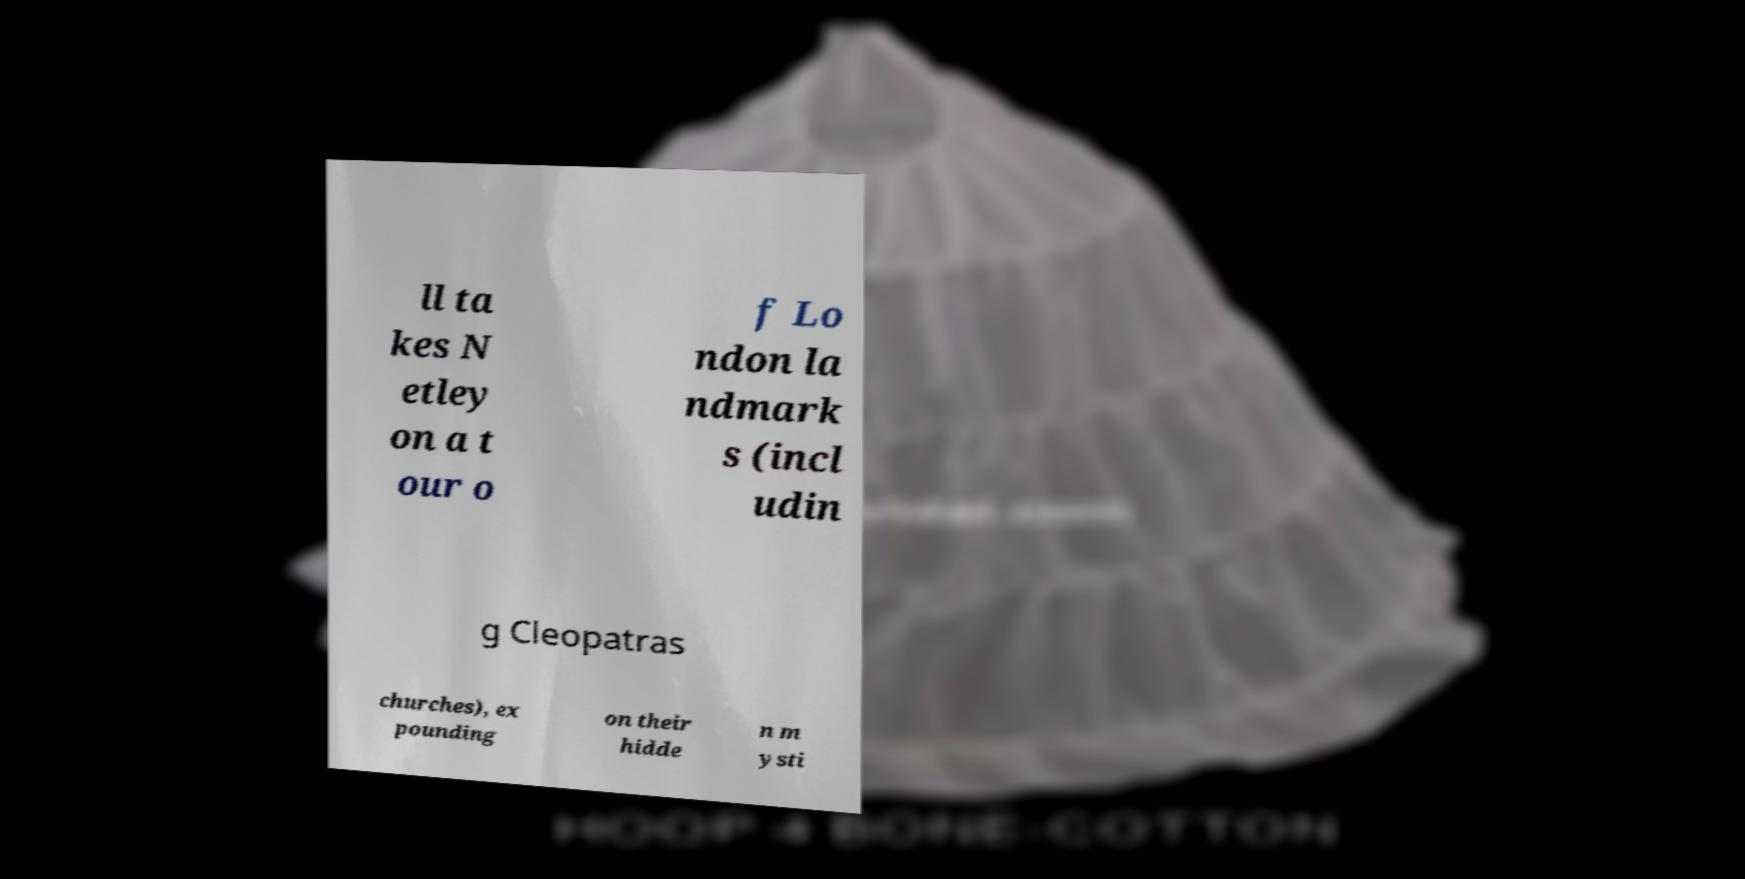There's text embedded in this image that I need extracted. Can you transcribe it verbatim? ll ta kes N etley on a t our o f Lo ndon la ndmark s (incl udin g Cleopatras churches), ex pounding on their hidde n m ysti 